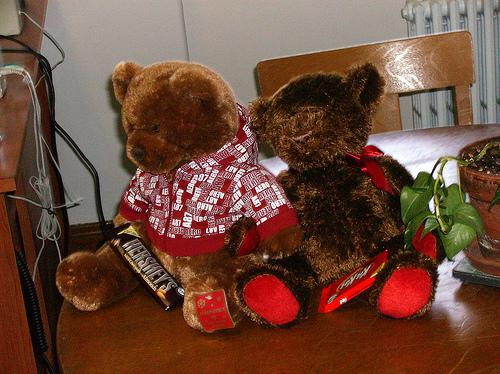Question: why is the room so bright?
Choices:
A. The lights are turned on.
B. The curtains are open.
C. The walls are painted white.
D. The flash is on.
Answer with the letter. Answer: A Question: how close are the bears to each other?
Choices:
A. 10 feet.
B. 100 yards.
C. Very close.
D. 1 foot.
Answer with the letter. Answer: C Question: what is the bear on the right wearing?
Choices:
A. A red bow.
B. A hat.
C. Pants.
D. A sweater.
Answer with the letter. Answer: A Question: where are the bears sitting?
Choices:
A. On a tree limb.
B. On the table.
C. On your car.
D. In a dumpster.
Answer with the letter. Answer: B Question: who is holding a hershey's bar?
Choices:
A. The girl.
B. The boy.
C. The mother.
D. The bear on the left.
Answer with the letter. Answer: D 